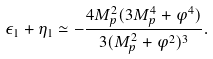<formula> <loc_0><loc_0><loc_500><loc_500>\epsilon _ { 1 } + \eta _ { 1 } \simeq - \frac { 4 M _ { p } ^ { 2 } ( 3 M _ { p } ^ { 4 } + \varphi ^ { 4 } ) } { 3 ( M _ { p } ^ { 2 } + \varphi ^ { 2 } ) ^ { 3 } } .</formula> 